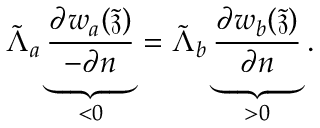<formula> <loc_0><loc_0><loc_500><loc_500>\tilde { \Lambda } _ { a } \underbrace { \frac { \partial w _ { a } ( \tilde { \mathfrak { z } } ) } { - \partial n } } _ { < 0 } = \tilde { \Lambda } _ { b } \underbrace { \frac { \partial w _ { b } ( \tilde { \mathfrak { z } } ) } { \partial n } } _ { > 0 } .</formula> 